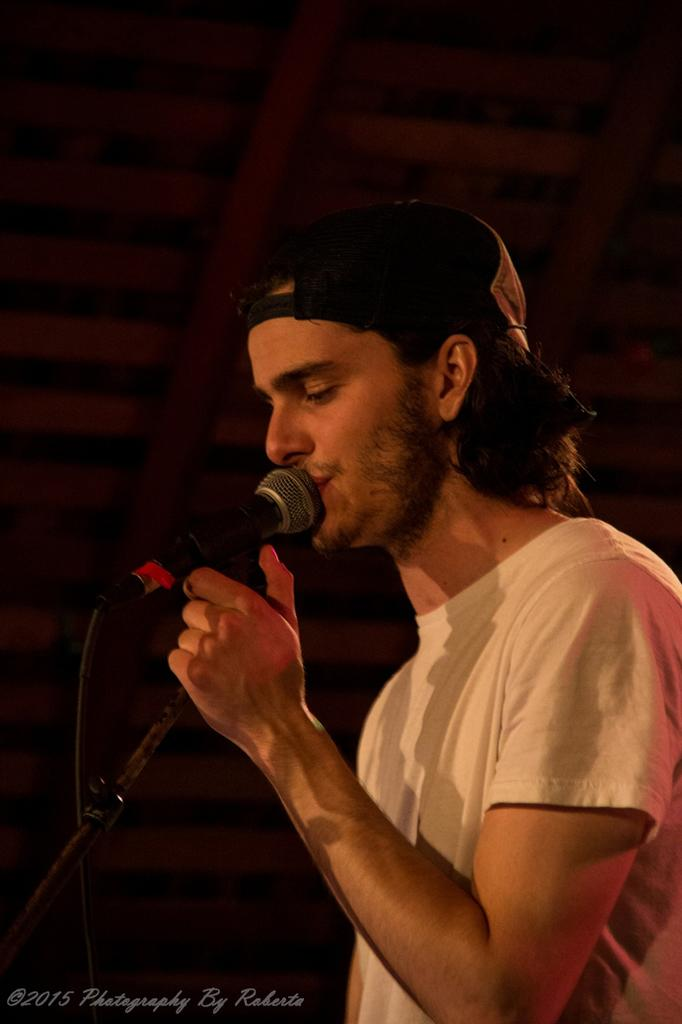Who is the main subject in the image? There is a man in the image. What is the man wearing? The man is wearing a white t-shirt. What is the man holding in the image? The man is holding a microphone with a stand. What is the man doing in the image? The man is singing a song. What can be seen in the background of the image? There is a wall in the background of the image. What type of advertisement is displayed on the man's skin in the image? There is no advertisement displayed on the man's skin in the image. Where can you find the man selling his products in the image? The image does not depict the man selling products at a market or any other location. 